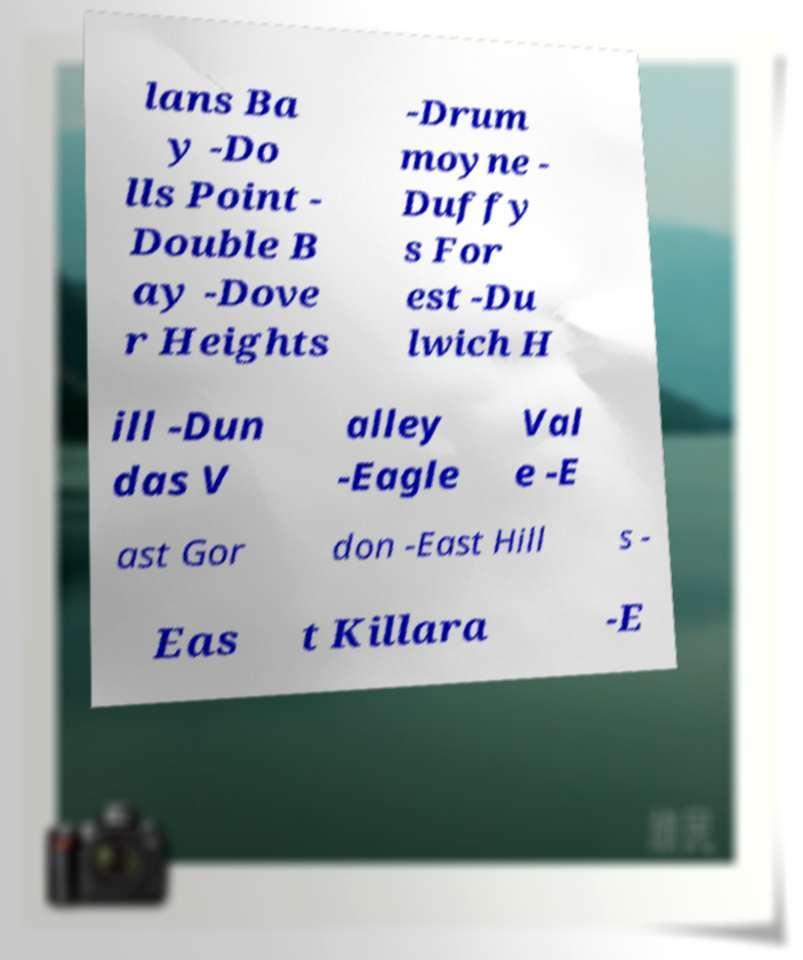Can you read and provide the text displayed in the image?This photo seems to have some interesting text. Can you extract and type it out for me? lans Ba y -Do lls Point - Double B ay -Dove r Heights -Drum moyne - Duffy s For est -Du lwich H ill -Dun das V alley -Eagle Val e -E ast Gor don -East Hill s - Eas t Killara -E 